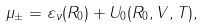<formula> <loc_0><loc_0><loc_500><loc_500>\mu _ { \pm } = \varepsilon _ { \nu } ( R _ { 0 } ) + U _ { 0 } ( R _ { 0 } , V , T ) ,</formula> 